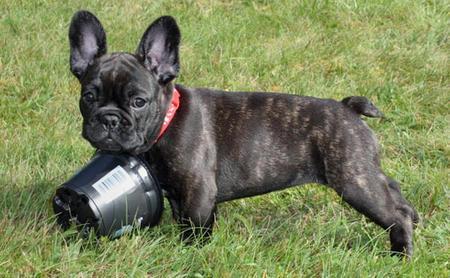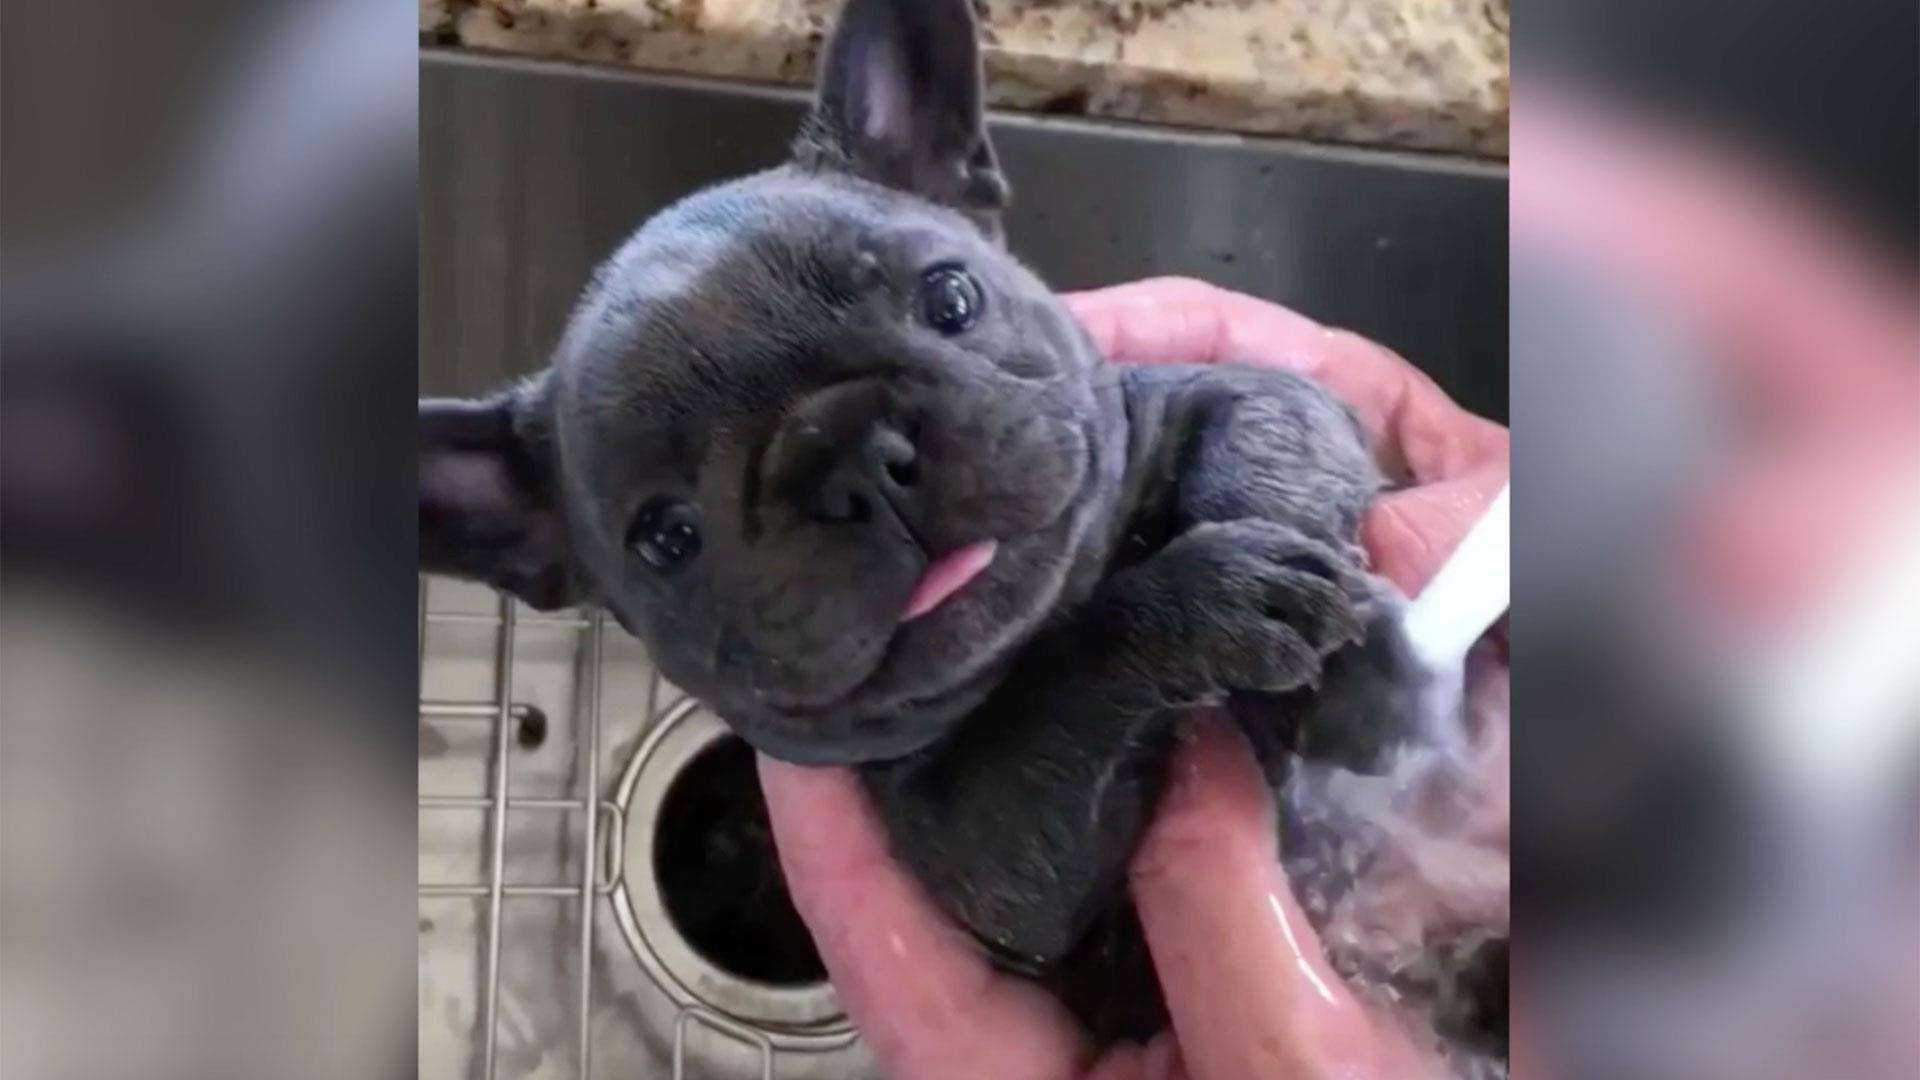The first image is the image on the left, the second image is the image on the right. Examine the images to the left and right. Is the description "The french bulldog in the left image wears a collar and has a black container in front of its chest." accurate? Answer yes or no. Yes. The first image is the image on the left, the second image is the image on the right. Given the left and right images, does the statement "There are at least 3 dogs." hold true? Answer yes or no. No. 